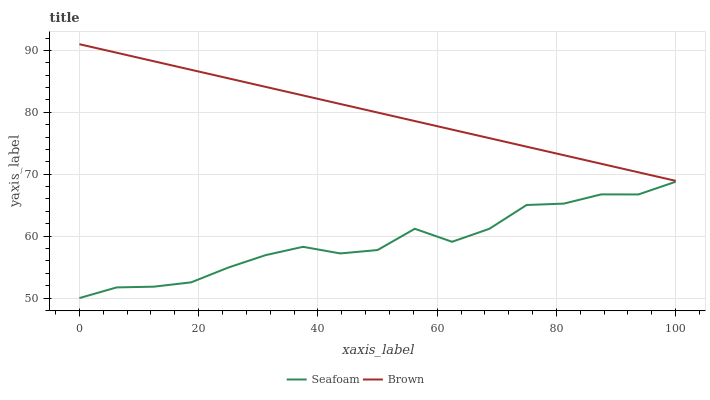Does Seafoam have the minimum area under the curve?
Answer yes or no. Yes. Does Brown have the maximum area under the curve?
Answer yes or no. Yes. Does Seafoam have the maximum area under the curve?
Answer yes or no. No. Is Brown the smoothest?
Answer yes or no. Yes. Is Seafoam the roughest?
Answer yes or no. Yes. Is Seafoam the smoothest?
Answer yes or no. No. Does Seafoam have the lowest value?
Answer yes or no. Yes. Does Brown have the highest value?
Answer yes or no. Yes. Does Seafoam have the highest value?
Answer yes or no. No. Is Seafoam less than Brown?
Answer yes or no. Yes. Is Brown greater than Seafoam?
Answer yes or no. Yes. Does Seafoam intersect Brown?
Answer yes or no. No. 